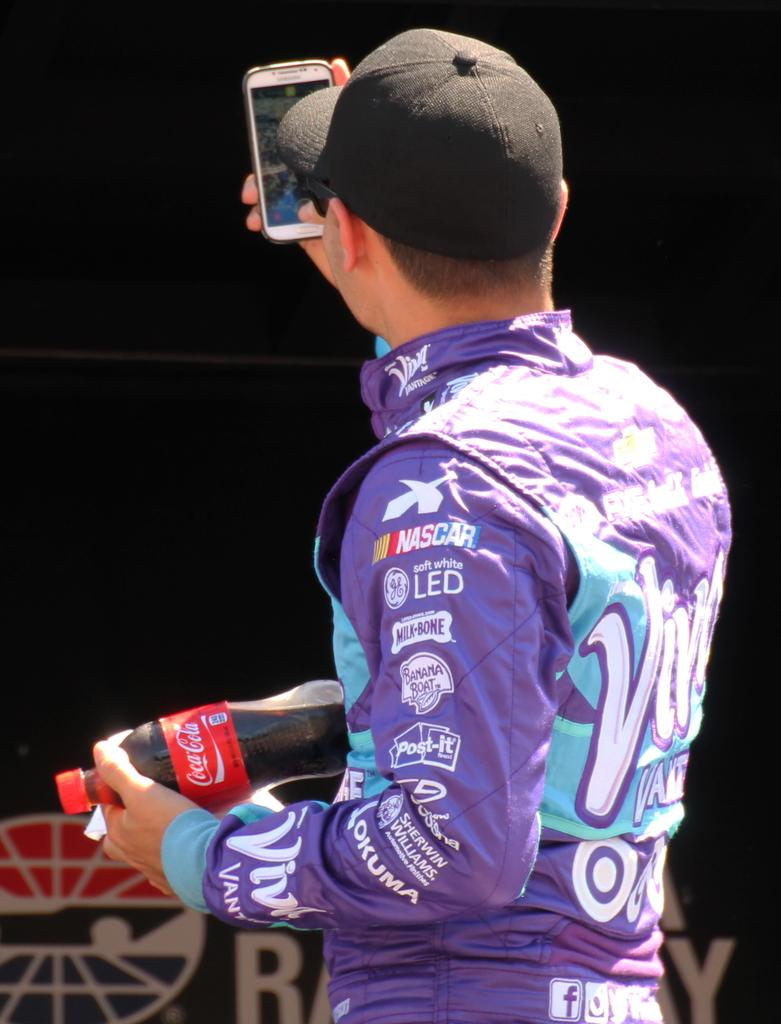<image>
Share a concise interpretation of the image provided. The back of a NASCAR driver dressed in purple jumpsuit carrying a coca cola bottle 